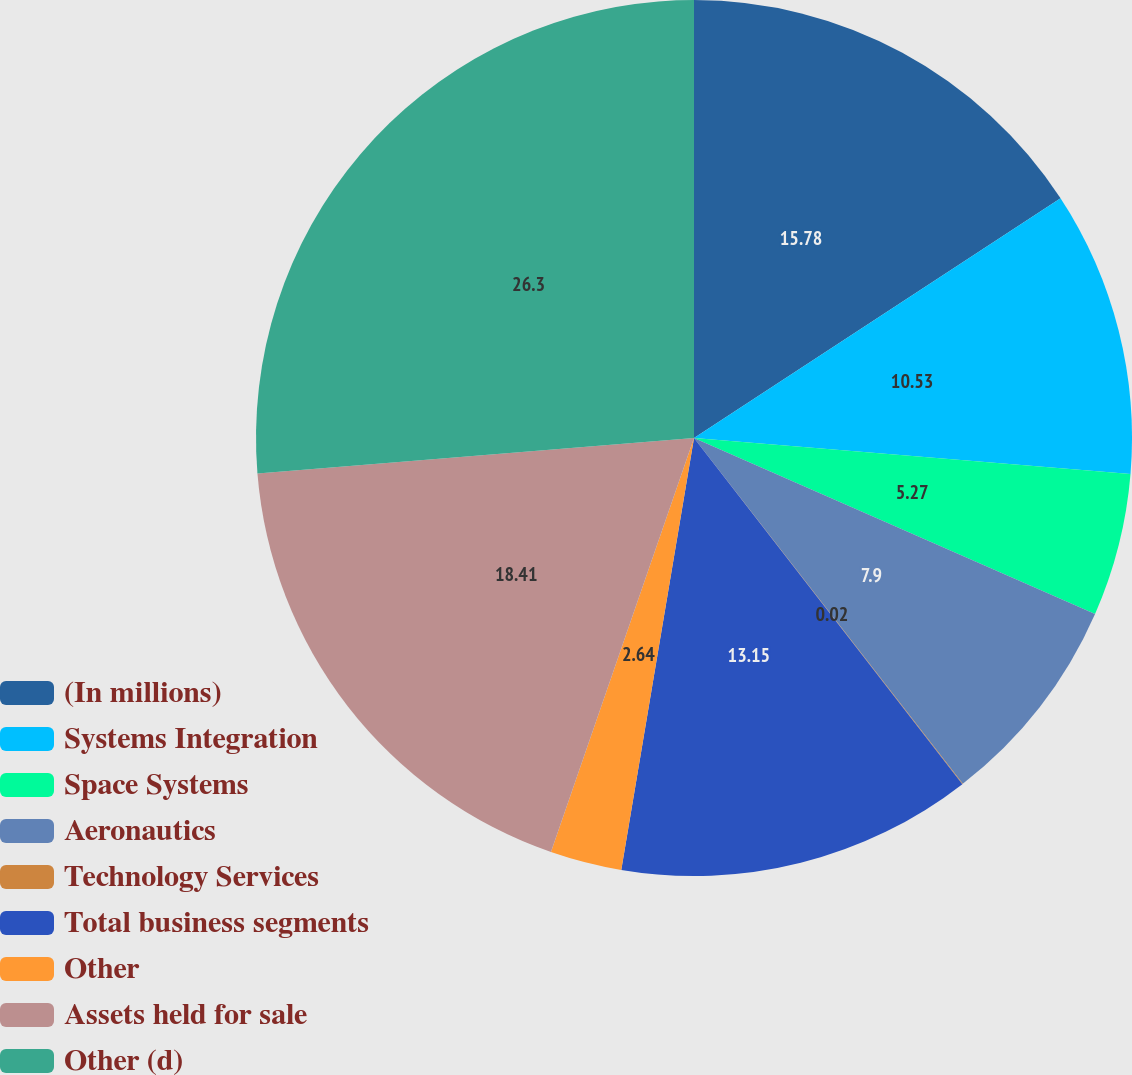<chart> <loc_0><loc_0><loc_500><loc_500><pie_chart><fcel>(In millions)<fcel>Systems Integration<fcel>Space Systems<fcel>Aeronautics<fcel>Technology Services<fcel>Total business segments<fcel>Other<fcel>Assets held for sale<fcel>Other (d)<nl><fcel>15.78%<fcel>10.53%<fcel>5.27%<fcel>7.9%<fcel>0.02%<fcel>13.15%<fcel>2.64%<fcel>18.41%<fcel>26.29%<nl></chart> 